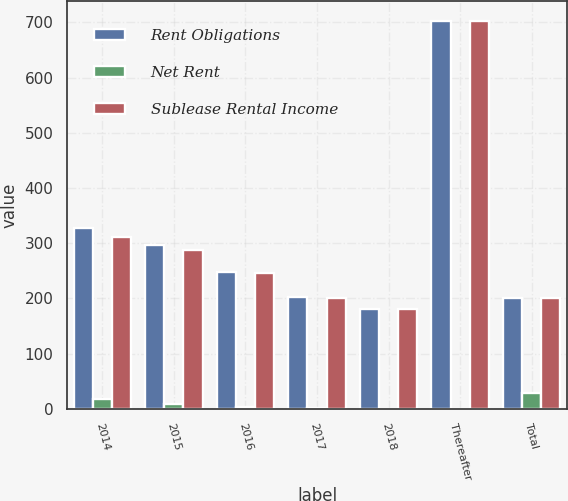Convert chart to OTSL. <chart><loc_0><loc_0><loc_500><loc_500><stacked_bar_chart><ecel><fcel>2014<fcel>2015<fcel>2016<fcel>2017<fcel>2018<fcel>Thereafter<fcel>Total<nl><fcel>Rent Obligations<fcel>327.6<fcel>296.9<fcel>247.9<fcel>201.9<fcel>180.2<fcel>702.7<fcel>201.3<nl><fcel>Net Rent<fcel>17<fcel>8.5<fcel>2.6<fcel>0.6<fcel>0<fcel>0<fcel>28.7<nl><fcel>Sublease Rental Income<fcel>310.6<fcel>288.4<fcel>245.3<fcel>201.3<fcel>180.2<fcel>702.7<fcel>201.3<nl></chart> 